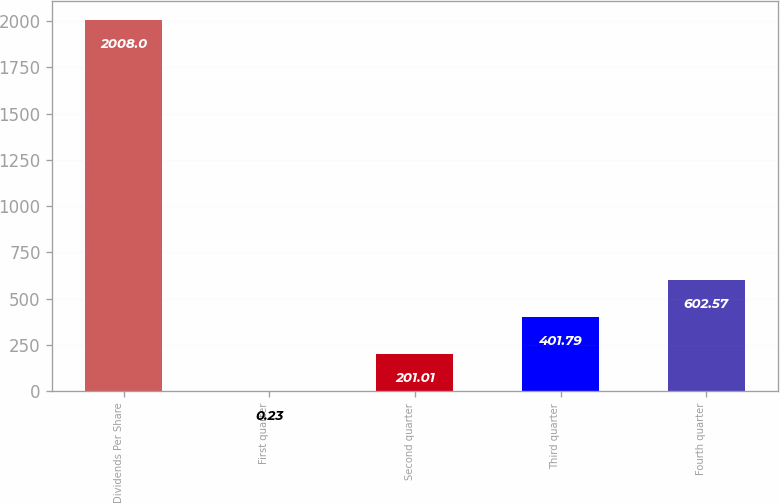Convert chart to OTSL. <chart><loc_0><loc_0><loc_500><loc_500><bar_chart><fcel>Dividends Per Share<fcel>First quarter<fcel>Second quarter<fcel>Third quarter<fcel>Fourth quarter<nl><fcel>2008<fcel>0.23<fcel>201.01<fcel>401.79<fcel>602.57<nl></chart> 